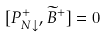<formula> <loc_0><loc_0><loc_500><loc_500>[ P _ { N \downarrow } ^ { + } , \widetilde { B } ^ { + } ] = 0</formula> 